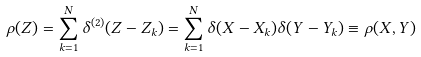Convert formula to latex. <formula><loc_0><loc_0><loc_500><loc_500>\rho ( Z ) = \sum _ { k = 1 } ^ { N } \delta ^ { ( 2 ) } ( Z - Z _ { k } ) = \sum _ { k = 1 } ^ { N } \delta ( X - X _ { k } ) \delta ( Y - Y _ { k } ) \equiv \rho ( X , Y )</formula> 